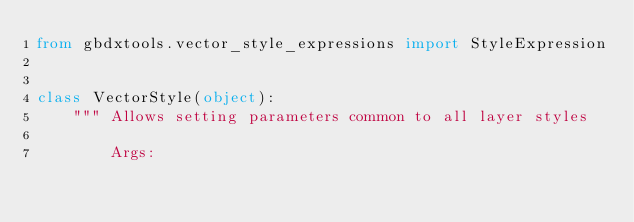<code> <loc_0><loc_0><loc_500><loc_500><_Python_>from gbdxtools.vector_style_expressions import StyleExpression


class VectorStyle(object):
    """ Allows setting parameters common to all layer styles

        Args:</code> 